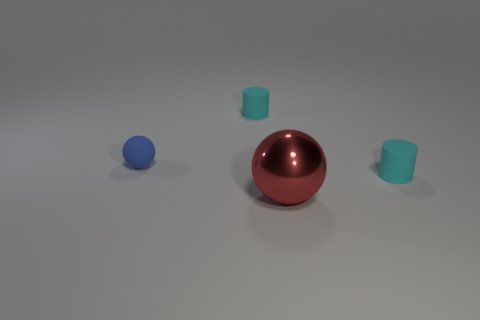Is there any other thing that is made of the same material as the large red ball?
Make the answer very short. No. Are there more blue balls in front of the tiny blue object than large red objects behind the large metal ball?
Offer a very short reply. No. Are the large object and the blue object made of the same material?
Your response must be concise. No. What is the shape of the object that is in front of the small matte ball and behind the red shiny ball?
Ensure brevity in your answer.  Cylinder. Are any tiny blue matte balls visible?
Provide a succinct answer. Yes. There is a sphere that is to the left of the large red metal thing; is there a tiny cylinder that is to the right of it?
Ensure brevity in your answer.  Yes. There is a small blue thing that is the same shape as the large metal object; what material is it?
Offer a terse response. Rubber. Is the number of balls greater than the number of tiny blue objects?
Give a very brief answer. Yes. Is the color of the small rubber sphere the same as the matte thing behind the tiny blue object?
Keep it short and to the point. No. How many other objects are the same material as the red ball?
Give a very brief answer. 0. 